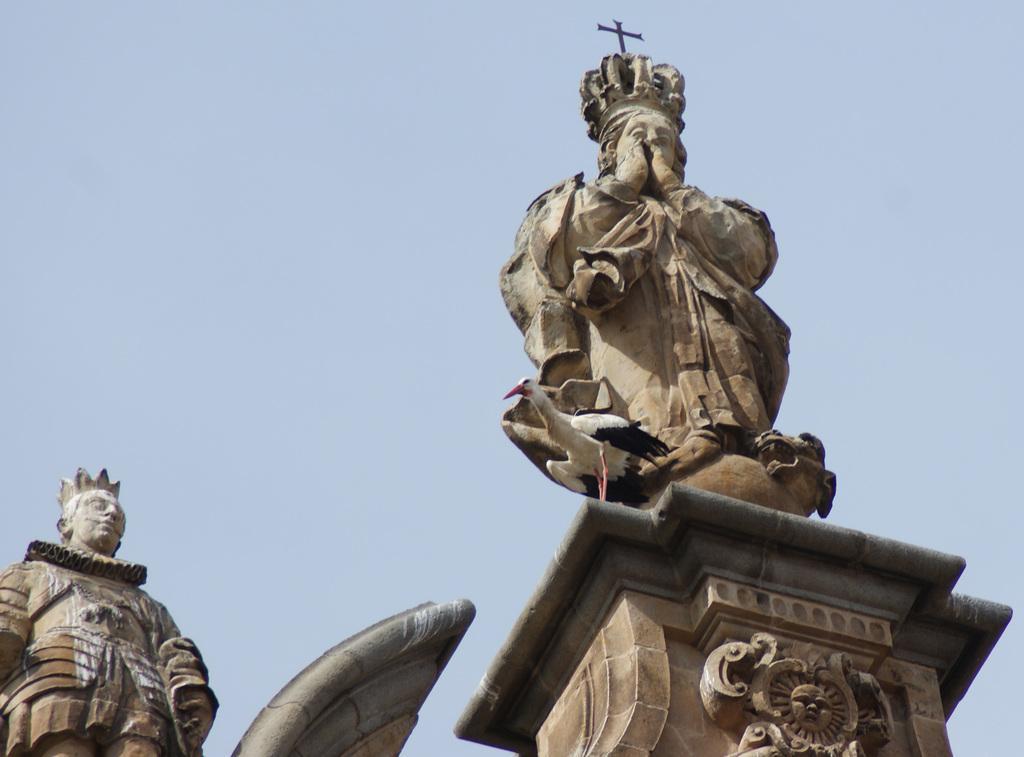Can you describe this image briefly? In this image we can see two statutes, a bird on the pillar and sky in the background. 